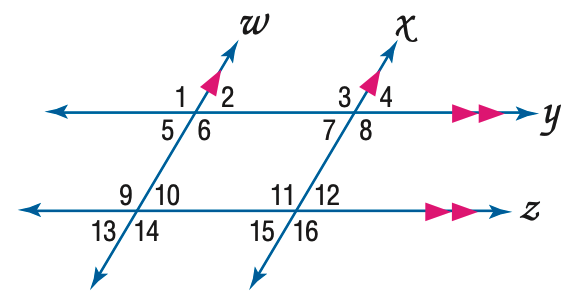Answer the mathemtical geometry problem and directly provide the correct option letter.
Question: In the figure, m \angle 12 = 64. Find the measure of \angle 13.
Choices: A: 54 B: 64 C: 74 D: 84 B 